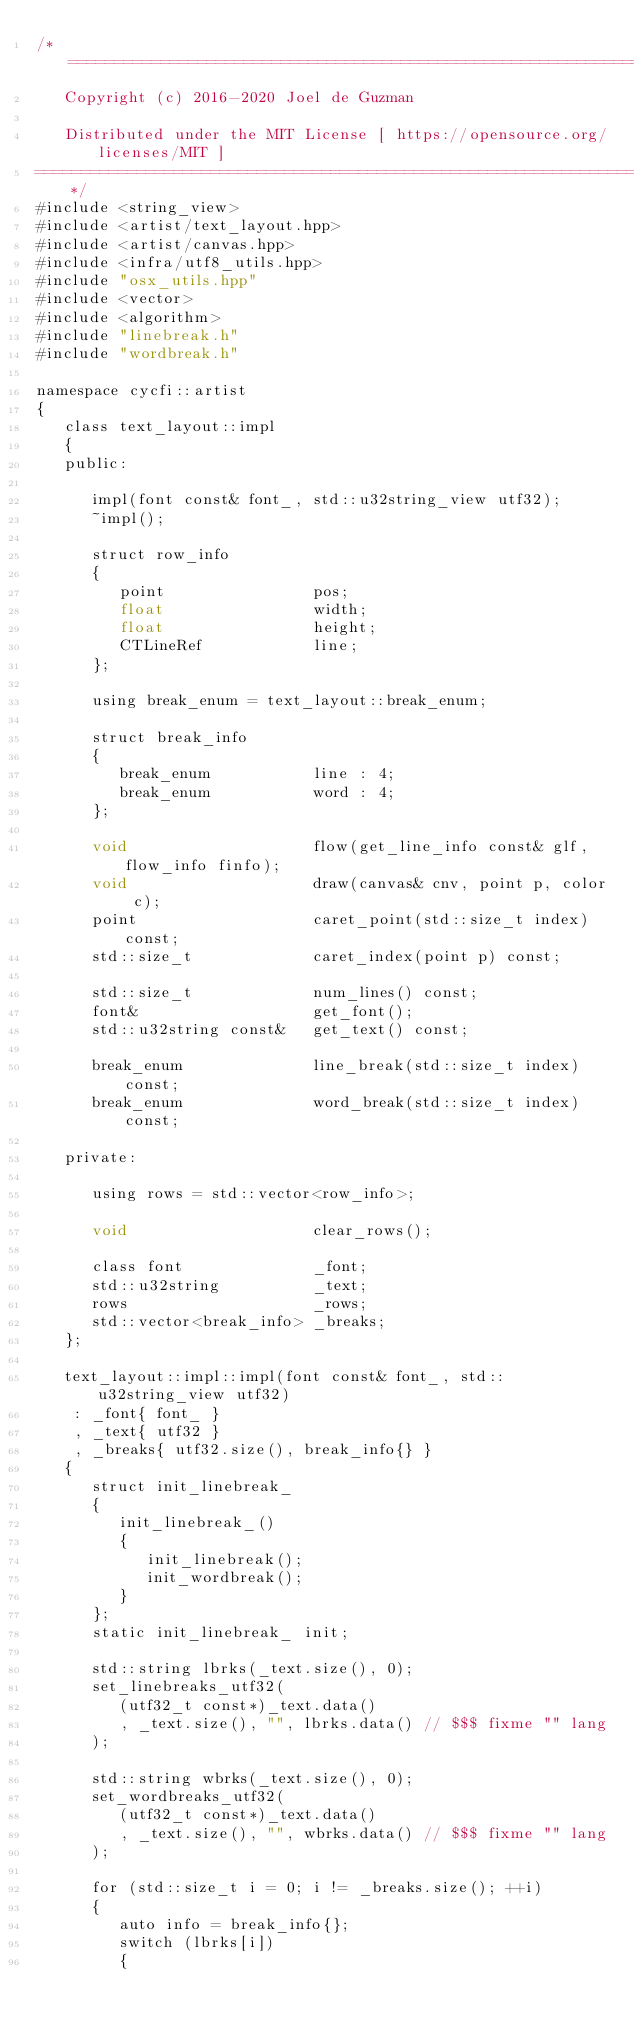Convert code to text. <code><loc_0><loc_0><loc_500><loc_500><_ObjectiveC_>/*=============================================================================
   Copyright (c) 2016-2020 Joel de Guzman

   Distributed under the MIT License [ https://opensource.org/licenses/MIT ]
=============================================================================*/
#include <string_view>
#include <artist/text_layout.hpp>
#include <artist/canvas.hpp>
#include <infra/utf8_utils.hpp>
#include "osx_utils.hpp"
#include <vector>
#include <algorithm>
#include "linebreak.h"
#include "wordbreak.h"

namespace cycfi::artist
{
   class text_layout::impl
   {
   public:

      impl(font const& font_, std::u32string_view utf32);
      ~impl();

      struct row_info
      {
         point                pos;
         float                width;
         float                height;
         CTLineRef            line;
      };

      using break_enum = text_layout::break_enum;

      struct break_info
      {
         break_enum           line : 4;
         break_enum           word : 4;
      };

      void                    flow(get_line_info const& glf, flow_info finfo);
      void                    draw(canvas& cnv, point p, color c);
      point                   caret_point(std::size_t index) const;
      std::size_t             caret_index(point p) const;

      std::size_t             num_lines() const;
      font&                   get_font();
      std::u32string const&   get_text() const;

      break_enum              line_break(std::size_t index) const;
      break_enum              word_break(std::size_t index) const;

   private:

      using rows = std::vector<row_info>;

      void                    clear_rows();

      class font              _font;
      std::u32string          _text;
      rows                    _rows;
      std::vector<break_info> _breaks;
   };

   text_layout::impl::impl(font const& font_, std::u32string_view utf32)
    : _font{ font_ }
    , _text{ utf32 }
    , _breaks{ utf32.size(), break_info{} }
   {
      struct init_linebreak_
      {
         init_linebreak_()
         {
            init_linebreak();
            init_wordbreak();
         }
      };
      static init_linebreak_ init;

      std::string lbrks(_text.size(), 0);
      set_linebreaks_utf32(
         (utf32_t const*)_text.data()
         , _text.size(), "", lbrks.data() // $$$ fixme "" lang
      );

      std::string wbrks(_text.size(), 0);
      set_wordbreaks_utf32(
         (utf32_t const*)_text.data()
         , _text.size(), "", wbrks.data() // $$$ fixme "" lang
      );

      for (std::size_t i = 0; i != _breaks.size(); ++i)
      {
         auto info = break_info{};
         switch (lbrks[i])
         {</code> 